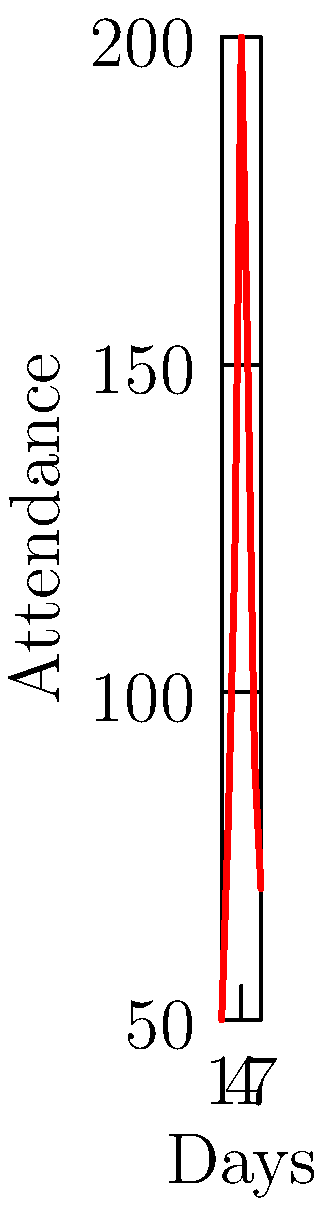Based on the graph showing customer attendance at your pub's folk music nights over a week, estimate how many 50-liter beer kegs you should prepare for the busiest night if each customer drinks an average of 0.5 liters of beer. To solve this problem, we need to follow these steps:

1. Identify the highest attendance from the graph:
   The peak attendance is on day 4 with 200 customers.

2. Calculate the total beer consumption for the busiest night:
   $$ \text{Total beer} = \text{Number of customers} \times \text{Average consumption per customer} $$
   $$ \text{Total beer} = 200 \times 0.5 \text{ liters} = 100 \text{ liters} $$

3. Calculate the number of 50-liter kegs needed:
   $$ \text{Number of kegs} = \frac{\text{Total beer}}{\text{Capacity of one keg}} $$
   $$ \text{Number of kegs} = \frac{100 \text{ liters}}{50 \text{ liters/keg}} = 2 \text{ kegs} $$

Therefore, you should prepare 2 kegs of 50 liters each for the busiest night.
Answer: 2 kegs 